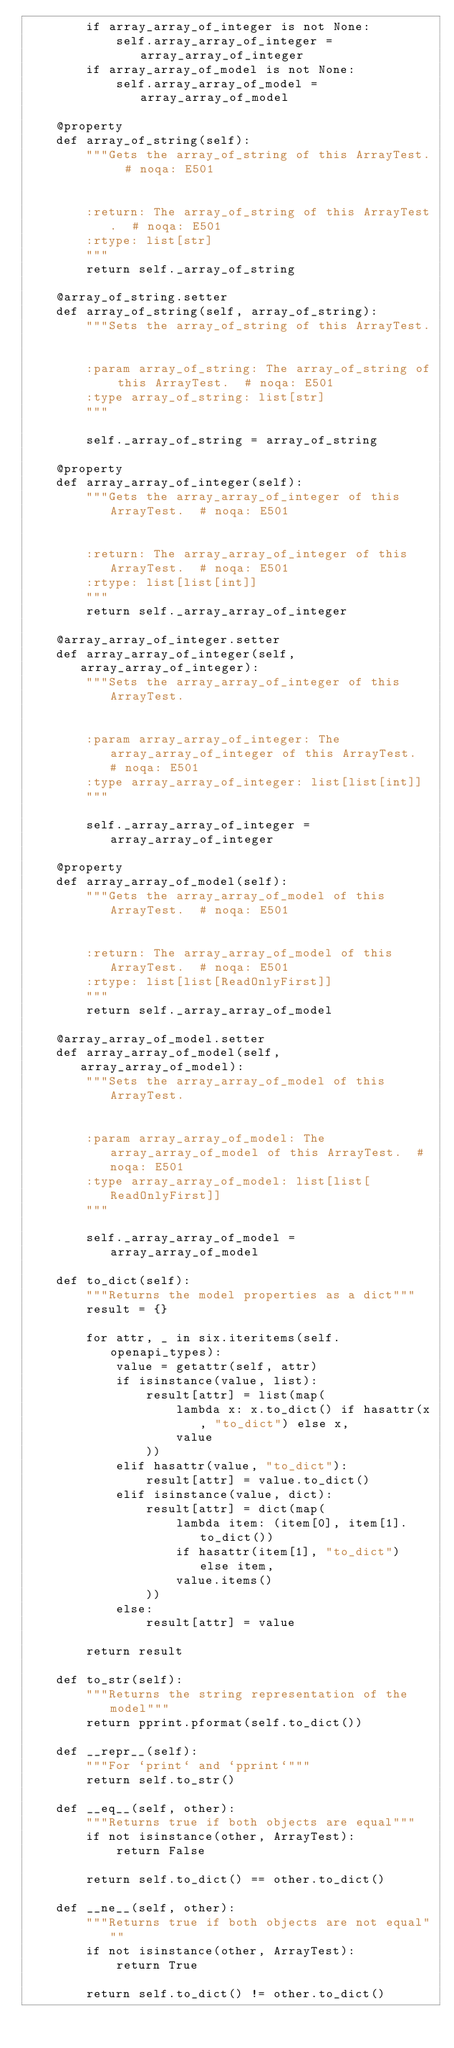<code> <loc_0><loc_0><loc_500><loc_500><_Python_>        if array_array_of_integer is not None:
            self.array_array_of_integer = array_array_of_integer
        if array_array_of_model is not None:
            self.array_array_of_model = array_array_of_model

    @property
    def array_of_string(self):
        """Gets the array_of_string of this ArrayTest.  # noqa: E501


        :return: The array_of_string of this ArrayTest.  # noqa: E501
        :rtype: list[str]
        """
        return self._array_of_string

    @array_of_string.setter
    def array_of_string(self, array_of_string):
        """Sets the array_of_string of this ArrayTest.


        :param array_of_string: The array_of_string of this ArrayTest.  # noqa: E501
        :type array_of_string: list[str]
        """

        self._array_of_string = array_of_string

    @property
    def array_array_of_integer(self):
        """Gets the array_array_of_integer of this ArrayTest.  # noqa: E501


        :return: The array_array_of_integer of this ArrayTest.  # noqa: E501
        :rtype: list[list[int]]
        """
        return self._array_array_of_integer

    @array_array_of_integer.setter
    def array_array_of_integer(self, array_array_of_integer):
        """Sets the array_array_of_integer of this ArrayTest.


        :param array_array_of_integer: The array_array_of_integer of this ArrayTest.  # noqa: E501
        :type array_array_of_integer: list[list[int]]
        """

        self._array_array_of_integer = array_array_of_integer

    @property
    def array_array_of_model(self):
        """Gets the array_array_of_model of this ArrayTest.  # noqa: E501


        :return: The array_array_of_model of this ArrayTest.  # noqa: E501
        :rtype: list[list[ReadOnlyFirst]]
        """
        return self._array_array_of_model

    @array_array_of_model.setter
    def array_array_of_model(self, array_array_of_model):
        """Sets the array_array_of_model of this ArrayTest.


        :param array_array_of_model: The array_array_of_model of this ArrayTest.  # noqa: E501
        :type array_array_of_model: list[list[ReadOnlyFirst]]
        """

        self._array_array_of_model = array_array_of_model

    def to_dict(self):
        """Returns the model properties as a dict"""
        result = {}

        for attr, _ in six.iteritems(self.openapi_types):
            value = getattr(self, attr)
            if isinstance(value, list):
                result[attr] = list(map(
                    lambda x: x.to_dict() if hasattr(x, "to_dict") else x,
                    value
                ))
            elif hasattr(value, "to_dict"):
                result[attr] = value.to_dict()
            elif isinstance(value, dict):
                result[attr] = dict(map(
                    lambda item: (item[0], item[1].to_dict())
                    if hasattr(item[1], "to_dict") else item,
                    value.items()
                ))
            else:
                result[attr] = value

        return result

    def to_str(self):
        """Returns the string representation of the model"""
        return pprint.pformat(self.to_dict())

    def __repr__(self):
        """For `print` and `pprint`"""
        return self.to_str()

    def __eq__(self, other):
        """Returns true if both objects are equal"""
        if not isinstance(other, ArrayTest):
            return False

        return self.to_dict() == other.to_dict()

    def __ne__(self, other):
        """Returns true if both objects are not equal"""
        if not isinstance(other, ArrayTest):
            return True

        return self.to_dict() != other.to_dict()
</code> 